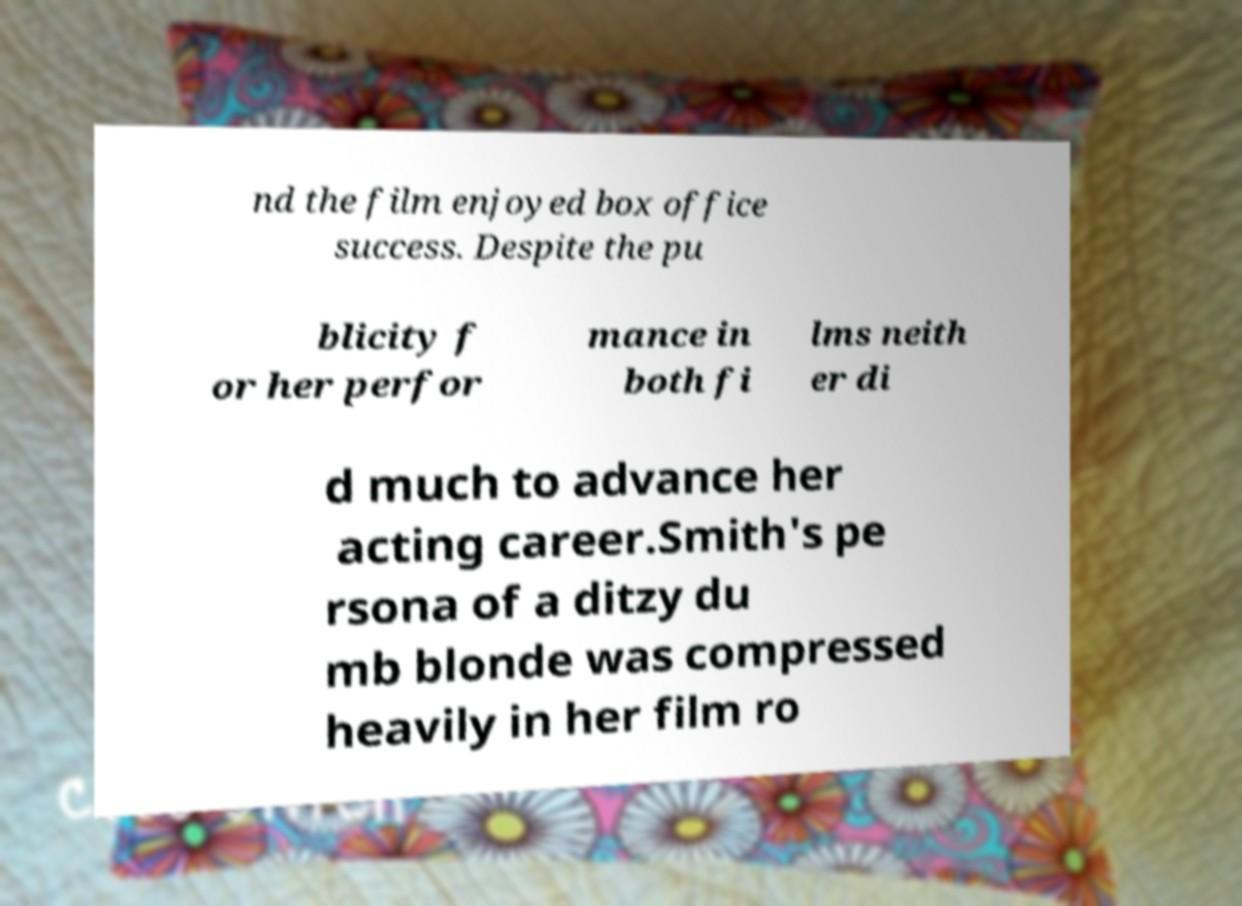Can you read and provide the text displayed in the image?This photo seems to have some interesting text. Can you extract and type it out for me? nd the film enjoyed box office success. Despite the pu blicity f or her perfor mance in both fi lms neith er di d much to advance her acting career.Smith's pe rsona of a ditzy du mb blonde was compressed heavily in her film ro 